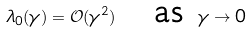Convert formula to latex. <formula><loc_0><loc_0><loc_500><loc_500>\lambda _ { 0 } ( \gamma ) = \mathcal { O } ( \gamma ^ { 2 } ) \quad \text {as } \gamma \rightarrow 0</formula> 